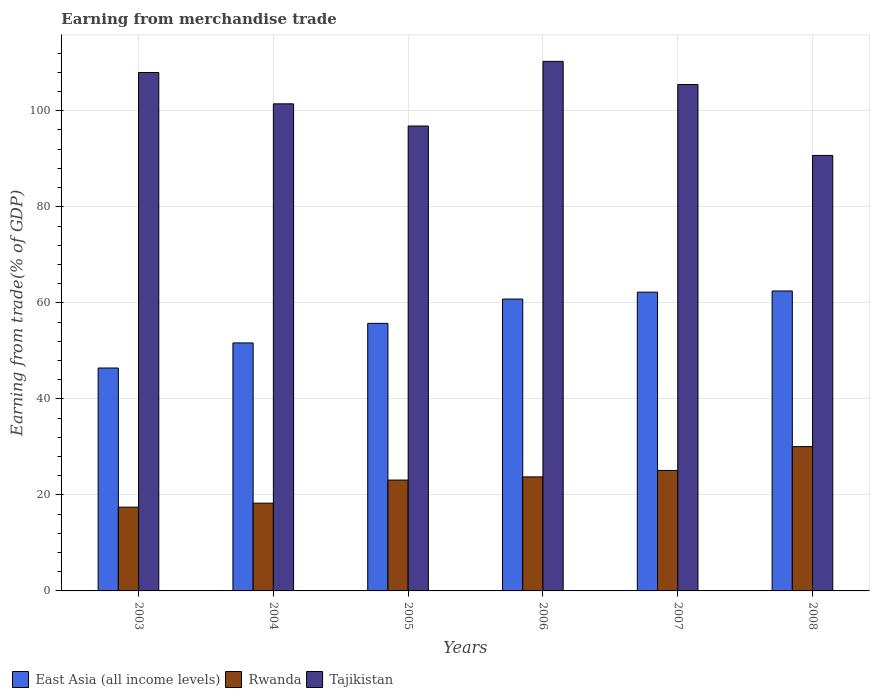Are the number of bars per tick equal to the number of legend labels?
Offer a very short reply. Yes. What is the label of the 4th group of bars from the left?
Give a very brief answer. 2006. What is the earnings from trade in Tajikistan in 2003?
Offer a very short reply. 107.97. Across all years, what is the maximum earnings from trade in Tajikistan?
Your response must be concise. 110.29. Across all years, what is the minimum earnings from trade in Rwanda?
Offer a terse response. 17.44. In which year was the earnings from trade in East Asia (all income levels) minimum?
Give a very brief answer. 2003. What is the total earnings from trade in Tajikistan in the graph?
Your answer should be compact. 612.71. What is the difference between the earnings from trade in East Asia (all income levels) in 2004 and that in 2006?
Ensure brevity in your answer.  -9.14. What is the difference between the earnings from trade in Rwanda in 2008 and the earnings from trade in Tajikistan in 2006?
Keep it short and to the point. -80.24. What is the average earnings from trade in Tajikistan per year?
Offer a terse response. 102.12. In the year 2004, what is the difference between the earnings from trade in East Asia (all income levels) and earnings from trade in Rwanda?
Ensure brevity in your answer.  33.37. In how many years, is the earnings from trade in Rwanda greater than 12 %?
Keep it short and to the point. 6. What is the ratio of the earnings from trade in East Asia (all income levels) in 2003 to that in 2005?
Ensure brevity in your answer.  0.83. What is the difference between the highest and the second highest earnings from trade in Tajikistan?
Offer a very short reply. 2.32. What is the difference between the highest and the lowest earnings from trade in Tajikistan?
Your response must be concise. 19.59. Is the sum of the earnings from trade in East Asia (all income levels) in 2003 and 2006 greater than the maximum earnings from trade in Tajikistan across all years?
Offer a terse response. No. What does the 2nd bar from the left in 2006 represents?
Ensure brevity in your answer.  Rwanda. What does the 3rd bar from the right in 2006 represents?
Ensure brevity in your answer.  East Asia (all income levels). How many bars are there?
Ensure brevity in your answer.  18. Are all the bars in the graph horizontal?
Ensure brevity in your answer.  No. What is the difference between two consecutive major ticks on the Y-axis?
Ensure brevity in your answer.  20. Does the graph contain any zero values?
Make the answer very short. No. Where does the legend appear in the graph?
Make the answer very short. Bottom left. How many legend labels are there?
Keep it short and to the point. 3. What is the title of the graph?
Ensure brevity in your answer.  Earning from merchandise trade. Does "Faeroe Islands" appear as one of the legend labels in the graph?
Provide a succinct answer. No. What is the label or title of the Y-axis?
Offer a terse response. Earning from trade(% of GDP). What is the Earning from trade(% of GDP) in East Asia (all income levels) in 2003?
Offer a very short reply. 46.43. What is the Earning from trade(% of GDP) in Rwanda in 2003?
Make the answer very short. 17.44. What is the Earning from trade(% of GDP) in Tajikistan in 2003?
Provide a succinct answer. 107.97. What is the Earning from trade(% of GDP) in East Asia (all income levels) in 2004?
Provide a succinct answer. 51.65. What is the Earning from trade(% of GDP) in Rwanda in 2004?
Your response must be concise. 18.28. What is the Earning from trade(% of GDP) of Tajikistan in 2004?
Provide a succinct answer. 101.45. What is the Earning from trade(% of GDP) in East Asia (all income levels) in 2005?
Ensure brevity in your answer.  55.72. What is the Earning from trade(% of GDP) in Rwanda in 2005?
Ensure brevity in your answer.  23.09. What is the Earning from trade(% of GDP) in Tajikistan in 2005?
Offer a terse response. 96.83. What is the Earning from trade(% of GDP) in East Asia (all income levels) in 2006?
Ensure brevity in your answer.  60.79. What is the Earning from trade(% of GDP) of Rwanda in 2006?
Give a very brief answer. 23.75. What is the Earning from trade(% of GDP) in Tajikistan in 2006?
Offer a terse response. 110.29. What is the Earning from trade(% of GDP) in East Asia (all income levels) in 2007?
Your answer should be compact. 62.22. What is the Earning from trade(% of GDP) in Rwanda in 2007?
Your answer should be very brief. 25.09. What is the Earning from trade(% of GDP) of Tajikistan in 2007?
Your response must be concise. 105.47. What is the Earning from trade(% of GDP) of East Asia (all income levels) in 2008?
Offer a very short reply. 62.47. What is the Earning from trade(% of GDP) of Rwanda in 2008?
Offer a terse response. 30.06. What is the Earning from trade(% of GDP) of Tajikistan in 2008?
Your answer should be very brief. 90.7. Across all years, what is the maximum Earning from trade(% of GDP) of East Asia (all income levels)?
Your answer should be compact. 62.47. Across all years, what is the maximum Earning from trade(% of GDP) of Rwanda?
Keep it short and to the point. 30.06. Across all years, what is the maximum Earning from trade(% of GDP) in Tajikistan?
Give a very brief answer. 110.29. Across all years, what is the minimum Earning from trade(% of GDP) of East Asia (all income levels)?
Provide a short and direct response. 46.43. Across all years, what is the minimum Earning from trade(% of GDP) of Rwanda?
Your answer should be compact. 17.44. Across all years, what is the minimum Earning from trade(% of GDP) of Tajikistan?
Your answer should be compact. 90.7. What is the total Earning from trade(% of GDP) of East Asia (all income levels) in the graph?
Offer a very short reply. 339.28. What is the total Earning from trade(% of GDP) in Rwanda in the graph?
Your answer should be very brief. 137.71. What is the total Earning from trade(% of GDP) in Tajikistan in the graph?
Keep it short and to the point. 612.71. What is the difference between the Earning from trade(% of GDP) in East Asia (all income levels) in 2003 and that in 2004?
Offer a very short reply. -5.22. What is the difference between the Earning from trade(% of GDP) in Rwanda in 2003 and that in 2004?
Your response must be concise. -0.84. What is the difference between the Earning from trade(% of GDP) in Tajikistan in 2003 and that in 2004?
Keep it short and to the point. 6.52. What is the difference between the Earning from trade(% of GDP) of East Asia (all income levels) in 2003 and that in 2005?
Keep it short and to the point. -9.3. What is the difference between the Earning from trade(% of GDP) in Rwanda in 2003 and that in 2005?
Your answer should be compact. -5.65. What is the difference between the Earning from trade(% of GDP) in Tajikistan in 2003 and that in 2005?
Your answer should be compact. 11.14. What is the difference between the Earning from trade(% of GDP) of East Asia (all income levels) in 2003 and that in 2006?
Your answer should be compact. -14.36. What is the difference between the Earning from trade(% of GDP) in Rwanda in 2003 and that in 2006?
Provide a succinct answer. -6.31. What is the difference between the Earning from trade(% of GDP) of Tajikistan in 2003 and that in 2006?
Your answer should be compact. -2.32. What is the difference between the Earning from trade(% of GDP) of East Asia (all income levels) in 2003 and that in 2007?
Offer a very short reply. -15.8. What is the difference between the Earning from trade(% of GDP) of Rwanda in 2003 and that in 2007?
Your response must be concise. -7.65. What is the difference between the Earning from trade(% of GDP) of East Asia (all income levels) in 2003 and that in 2008?
Your answer should be compact. -16.04. What is the difference between the Earning from trade(% of GDP) in Rwanda in 2003 and that in 2008?
Offer a very short reply. -12.61. What is the difference between the Earning from trade(% of GDP) of Tajikistan in 2003 and that in 2008?
Provide a short and direct response. 17.27. What is the difference between the Earning from trade(% of GDP) in East Asia (all income levels) in 2004 and that in 2005?
Your response must be concise. -4.08. What is the difference between the Earning from trade(% of GDP) of Rwanda in 2004 and that in 2005?
Provide a short and direct response. -4.81. What is the difference between the Earning from trade(% of GDP) in Tajikistan in 2004 and that in 2005?
Your answer should be compact. 4.62. What is the difference between the Earning from trade(% of GDP) of East Asia (all income levels) in 2004 and that in 2006?
Your answer should be very brief. -9.14. What is the difference between the Earning from trade(% of GDP) of Rwanda in 2004 and that in 2006?
Your response must be concise. -5.47. What is the difference between the Earning from trade(% of GDP) in Tajikistan in 2004 and that in 2006?
Your response must be concise. -8.85. What is the difference between the Earning from trade(% of GDP) of East Asia (all income levels) in 2004 and that in 2007?
Offer a terse response. -10.57. What is the difference between the Earning from trade(% of GDP) in Rwanda in 2004 and that in 2007?
Offer a terse response. -6.81. What is the difference between the Earning from trade(% of GDP) in Tajikistan in 2004 and that in 2007?
Provide a short and direct response. -4.02. What is the difference between the Earning from trade(% of GDP) of East Asia (all income levels) in 2004 and that in 2008?
Make the answer very short. -10.82. What is the difference between the Earning from trade(% of GDP) of Rwanda in 2004 and that in 2008?
Offer a terse response. -11.78. What is the difference between the Earning from trade(% of GDP) of Tajikistan in 2004 and that in 2008?
Offer a terse response. 10.75. What is the difference between the Earning from trade(% of GDP) of East Asia (all income levels) in 2005 and that in 2006?
Make the answer very short. -5.06. What is the difference between the Earning from trade(% of GDP) in Rwanda in 2005 and that in 2006?
Keep it short and to the point. -0.66. What is the difference between the Earning from trade(% of GDP) of Tajikistan in 2005 and that in 2006?
Your answer should be compact. -13.47. What is the difference between the Earning from trade(% of GDP) in East Asia (all income levels) in 2005 and that in 2007?
Make the answer very short. -6.5. What is the difference between the Earning from trade(% of GDP) in Rwanda in 2005 and that in 2007?
Your answer should be compact. -2. What is the difference between the Earning from trade(% of GDP) of Tajikistan in 2005 and that in 2007?
Provide a succinct answer. -8.64. What is the difference between the Earning from trade(% of GDP) of East Asia (all income levels) in 2005 and that in 2008?
Your response must be concise. -6.75. What is the difference between the Earning from trade(% of GDP) in Rwanda in 2005 and that in 2008?
Give a very brief answer. -6.97. What is the difference between the Earning from trade(% of GDP) in Tajikistan in 2005 and that in 2008?
Provide a succinct answer. 6.13. What is the difference between the Earning from trade(% of GDP) of East Asia (all income levels) in 2006 and that in 2007?
Give a very brief answer. -1.44. What is the difference between the Earning from trade(% of GDP) in Rwanda in 2006 and that in 2007?
Your answer should be very brief. -1.34. What is the difference between the Earning from trade(% of GDP) of Tajikistan in 2006 and that in 2007?
Offer a terse response. 4.82. What is the difference between the Earning from trade(% of GDP) of East Asia (all income levels) in 2006 and that in 2008?
Keep it short and to the point. -1.68. What is the difference between the Earning from trade(% of GDP) in Rwanda in 2006 and that in 2008?
Keep it short and to the point. -6.31. What is the difference between the Earning from trade(% of GDP) in Tajikistan in 2006 and that in 2008?
Provide a succinct answer. 19.59. What is the difference between the Earning from trade(% of GDP) in East Asia (all income levels) in 2007 and that in 2008?
Give a very brief answer. -0.25. What is the difference between the Earning from trade(% of GDP) of Rwanda in 2007 and that in 2008?
Provide a succinct answer. -4.96. What is the difference between the Earning from trade(% of GDP) in Tajikistan in 2007 and that in 2008?
Give a very brief answer. 14.77. What is the difference between the Earning from trade(% of GDP) in East Asia (all income levels) in 2003 and the Earning from trade(% of GDP) in Rwanda in 2004?
Keep it short and to the point. 28.15. What is the difference between the Earning from trade(% of GDP) in East Asia (all income levels) in 2003 and the Earning from trade(% of GDP) in Tajikistan in 2004?
Your response must be concise. -55.02. What is the difference between the Earning from trade(% of GDP) in Rwanda in 2003 and the Earning from trade(% of GDP) in Tajikistan in 2004?
Your response must be concise. -84. What is the difference between the Earning from trade(% of GDP) in East Asia (all income levels) in 2003 and the Earning from trade(% of GDP) in Rwanda in 2005?
Your answer should be very brief. 23.34. What is the difference between the Earning from trade(% of GDP) in East Asia (all income levels) in 2003 and the Earning from trade(% of GDP) in Tajikistan in 2005?
Give a very brief answer. -50.4. What is the difference between the Earning from trade(% of GDP) in Rwanda in 2003 and the Earning from trade(% of GDP) in Tajikistan in 2005?
Offer a very short reply. -79.38. What is the difference between the Earning from trade(% of GDP) in East Asia (all income levels) in 2003 and the Earning from trade(% of GDP) in Rwanda in 2006?
Keep it short and to the point. 22.68. What is the difference between the Earning from trade(% of GDP) of East Asia (all income levels) in 2003 and the Earning from trade(% of GDP) of Tajikistan in 2006?
Make the answer very short. -63.87. What is the difference between the Earning from trade(% of GDP) in Rwanda in 2003 and the Earning from trade(% of GDP) in Tajikistan in 2006?
Provide a succinct answer. -92.85. What is the difference between the Earning from trade(% of GDP) in East Asia (all income levels) in 2003 and the Earning from trade(% of GDP) in Rwanda in 2007?
Your answer should be compact. 21.33. What is the difference between the Earning from trade(% of GDP) of East Asia (all income levels) in 2003 and the Earning from trade(% of GDP) of Tajikistan in 2007?
Your response must be concise. -59.04. What is the difference between the Earning from trade(% of GDP) of Rwanda in 2003 and the Earning from trade(% of GDP) of Tajikistan in 2007?
Your answer should be compact. -88.03. What is the difference between the Earning from trade(% of GDP) of East Asia (all income levels) in 2003 and the Earning from trade(% of GDP) of Rwanda in 2008?
Your answer should be very brief. 16.37. What is the difference between the Earning from trade(% of GDP) of East Asia (all income levels) in 2003 and the Earning from trade(% of GDP) of Tajikistan in 2008?
Your response must be concise. -44.27. What is the difference between the Earning from trade(% of GDP) in Rwanda in 2003 and the Earning from trade(% of GDP) in Tajikistan in 2008?
Offer a terse response. -73.26. What is the difference between the Earning from trade(% of GDP) in East Asia (all income levels) in 2004 and the Earning from trade(% of GDP) in Rwanda in 2005?
Ensure brevity in your answer.  28.56. What is the difference between the Earning from trade(% of GDP) of East Asia (all income levels) in 2004 and the Earning from trade(% of GDP) of Tajikistan in 2005?
Offer a very short reply. -45.18. What is the difference between the Earning from trade(% of GDP) in Rwanda in 2004 and the Earning from trade(% of GDP) in Tajikistan in 2005?
Ensure brevity in your answer.  -78.55. What is the difference between the Earning from trade(% of GDP) of East Asia (all income levels) in 2004 and the Earning from trade(% of GDP) of Rwanda in 2006?
Your response must be concise. 27.9. What is the difference between the Earning from trade(% of GDP) of East Asia (all income levels) in 2004 and the Earning from trade(% of GDP) of Tajikistan in 2006?
Provide a succinct answer. -58.65. What is the difference between the Earning from trade(% of GDP) in Rwanda in 2004 and the Earning from trade(% of GDP) in Tajikistan in 2006?
Ensure brevity in your answer.  -92.02. What is the difference between the Earning from trade(% of GDP) in East Asia (all income levels) in 2004 and the Earning from trade(% of GDP) in Rwanda in 2007?
Your response must be concise. 26.56. What is the difference between the Earning from trade(% of GDP) in East Asia (all income levels) in 2004 and the Earning from trade(% of GDP) in Tajikistan in 2007?
Offer a terse response. -53.82. What is the difference between the Earning from trade(% of GDP) of Rwanda in 2004 and the Earning from trade(% of GDP) of Tajikistan in 2007?
Keep it short and to the point. -87.19. What is the difference between the Earning from trade(% of GDP) in East Asia (all income levels) in 2004 and the Earning from trade(% of GDP) in Rwanda in 2008?
Offer a terse response. 21.59. What is the difference between the Earning from trade(% of GDP) of East Asia (all income levels) in 2004 and the Earning from trade(% of GDP) of Tajikistan in 2008?
Provide a succinct answer. -39.05. What is the difference between the Earning from trade(% of GDP) of Rwanda in 2004 and the Earning from trade(% of GDP) of Tajikistan in 2008?
Make the answer very short. -72.42. What is the difference between the Earning from trade(% of GDP) in East Asia (all income levels) in 2005 and the Earning from trade(% of GDP) in Rwanda in 2006?
Your response must be concise. 31.98. What is the difference between the Earning from trade(% of GDP) of East Asia (all income levels) in 2005 and the Earning from trade(% of GDP) of Tajikistan in 2006?
Your answer should be compact. -54.57. What is the difference between the Earning from trade(% of GDP) in Rwanda in 2005 and the Earning from trade(% of GDP) in Tajikistan in 2006?
Make the answer very short. -87.21. What is the difference between the Earning from trade(% of GDP) of East Asia (all income levels) in 2005 and the Earning from trade(% of GDP) of Rwanda in 2007?
Your answer should be compact. 30.63. What is the difference between the Earning from trade(% of GDP) of East Asia (all income levels) in 2005 and the Earning from trade(% of GDP) of Tajikistan in 2007?
Offer a terse response. -49.75. What is the difference between the Earning from trade(% of GDP) in Rwanda in 2005 and the Earning from trade(% of GDP) in Tajikistan in 2007?
Provide a succinct answer. -82.38. What is the difference between the Earning from trade(% of GDP) in East Asia (all income levels) in 2005 and the Earning from trade(% of GDP) in Rwanda in 2008?
Make the answer very short. 25.67. What is the difference between the Earning from trade(% of GDP) in East Asia (all income levels) in 2005 and the Earning from trade(% of GDP) in Tajikistan in 2008?
Provide a short and direct response. -34.98. What is the difference between the Earning from trade(% of GDP) of Rwanda in 2005 and the Earning from trade(% of GDP) of Tajikistan in 2008?
Provide a short and direct response. -67.61. What is the difference between the Earning from trade(% of GDP) in East Asia (all income levels) in 2006 and the Earning from trade(% of GDP) in Rwanda in 2007?
Your answer should be compact. 35.69. What is the difference between the Earning from trade(% of GDP) of East Asia (all income levels) in 2006 and the Earning from trade(% of GDP) of Tajikistan in 2007?
Your answer should be very brief. -44.68. What is the difference between the Earning from trade(% of GDP) in Rwanda in 2006 and the Earning from trade(% of GDP) in Tajikistan in 2007?
Make the answer very short. -81.72. What is the difference between the Earning from trade(% of GDP) in East Asia (all income levels) in 2006 and the Earning from trade(% of GDP) in Rwanda in 2008?
Provide a succinct answer. 30.73. What is the difference between the Earning from trade(% of GDP) of East Asia (all income levels) in 2006 and the Earning from trade(% of GDP) of Tajikistan in 2008?
Offer a terse response. -29.91. What is the difference between the Earning from trade(% of GDP) in Rwanda in 2006 and the Earning from trade(% of GDP) in Tajikistan in 2008?
Keep it short and to the point. -66.95. What is the difference between the Earning from trade(% of GDP) in East Asia (all income levels) in 2007 and the Earning from trade(% of GDP) in Rwanda in 2008?
Your answer should be compact. 32.17. What is the difference between the Earning from trade(% of GDP) of East Asia (all income levels) in 2007 and the Earning from trade(% of GDP) of Tajikistan in 2008?
Offer a terse response. -28.48. What is the difference between the Earning from trade(% of GDP) of Rwanda in 2007 and the Earning from trade(% of GDP) of Tajikistan in 2008?
Offer a very short reply. -65.61. What is the average Earning from trade(% of GDP) in East Asia (all income levels) per year?
Give a very brief answer. 56.55. What is the average Earning from trade(% of GDP) of Rwanda per year?
Your response must be concise. 22.95. What is the average Earning from trade(% of GDP) in Tajikistan per year?
Offer a terse response. 102.12. In the year 2003, what is the difference between the Earning from trade(% of GDP) in East Asia (all income levels) and Earning from trade(% of GDP) in Rwanda?
Make the answer very short. 28.98. In the year 2003, what is the difference between the Earning from trade(% of GDP) in East Asia (all income levels) and Earning from trade(% of GDP) in Tajikistan?
Ensure brevity in your answer.  -61.54. In the year 2003, what is the difference between the Earning from trade(% of GDP) in Rwanda and Earning from trade(% of GDP) in Tajikistan?
Make the answer very short. -90.53. In the year 2004, what is the difference between the Earning from trade(% of GDP) of East Asia (all income levels) and Earning from trade(% of GDP) of Rwanda?
Provide a short and direct response. 33.37. In the year 2004, what is the difference between the Earning from trade(% of GDP) of East Asia (all income levels) and Earning from trade(% of GDP) of Tajikistan?
Your answer should be very brief. -49.8. In the year 2004, what is the difference between the Earning from trade(% of GDP) in Rwanda and Earning from trade(% of GDP) in Tajikistan?
Provide a succinct answer. -83.17. In the year 2005, what is the difference between the Earning from trade(% of GDP) in East Asia (all income levels) and Earning from trade(% of GDP) in Rwanda?
Offer a terse response. 32.64. In the year 2005, what is the difference between the Earning from trade(% of GDP) in East Asia (all income levels) and Earning from trade(% of GDP) in Tajikistan?
Make the answer very short. -41.1. In the year 2005, what is the difference between the Earning from trade(% of GDP) in Rwanda and Earning from trade(% of GDP) in Tajikistan?
Offer a terse response. -73.74. In the year 2006, what is the difference between the Earning from trade(% of GDP) of East Asia (all income levels) and Earning from trade(% of GDP) of Rwanda?
Make the answer very short. 37.04. In the year 2006, what is the difference between the Earning from trade(% of GDP) of East Asia (all income levels) and Earning from trade(% of GDP) of Tajikistan?
Ensure brevity in your answer.  -49.51. In the year 2006, what is the difference between the Earning from trade(% of GDP) in Rwanda and Earning from trade(% of GDP) in Tajikistan?
Give a very brief answer. -86.55. In the year 2007, what is the difference between the Earning from trade(% of GDP) in East Asia (all income levels) and Earning from trade(% of GDP) in Rwanda?
Your answer should be compact. 37.13. In the year 2007, what is the difference between the Earning from trade(% of GDP) in East Asia (all income levels) and Earning from trade(% of GDP) in Tajikistan?
Your answer should be very brief. -43.25. In the year 2007, what is the difference between the Earning from trade(% of GDP) in Rwanda and Earning from trade(% of GDP) in Tajikistan?
Offer a very short reply. -80.38. In the year 2008, what is the difference between the Earning from trade(% of GDP) in East Asia (all income levels) and Earning from trade(% of GDP) in Rwanda?
Provide a succinct answer. 32.41. In the year 2008, what is the difference between the Earning from trade(% of GDP) of East Asia (all income levels) and Earning from trade(% of GDP) of Tajikistan?
Ensure brevity in your answer.  -28.23. In the year 2008, what is the difference between the Earning from trade(% of GDP) in Rwanda and Earning from trade(% of GDP) in Tajikistan?
Offer a terse response. -60.64. What is the ratio of the Earning from trade(% of GDP) of East Asia (all income levels) in 2003 to that in 2004?
Provide a succinct answer. 0.9. What is the ratio of the Earning from trade(% of GDP) in Rwanda in 2003 to that in 2004?
Provide a short and direct response. 0.95. What is the ratio of the Earning from trade(% of GDP) in Tajikistan in 2003 to that in 2004?
Keep it short and to the point. 1.06. What is the ratio of the Earning from trade(% of GDP) of East Asia (all income levels) in 2003 to that in 2005?
Offer a terse response. 0.83. What is the ratio of the Earning from trade(% of GDP) of Rwanda in 2003 to that in 2005?
Your answer should be very brief. 0.76. What is the ratio of the Earning from trade(% of GDP) of Tajikistan in 2003 to that in 2005?
Offer a terse response. 1.12. What is the ratio of the Earning from trade(% of GDP) of East Asia (all income levels) in 2003 to that in 2006?
Your answer should be compact. 0.76. What is the ratio of the Earning from trade(% of GDP) in Rwanda in 2003 to that in 2006?
Provide a succinct answer. 0.73. What is the ratio of the Earning from trade(% of GDP) in Tajikistan in 2003 to that in 2006?
Give a very brief answer. 0.98. What is the ratio of the Earning from trade(% of GDP) of East Asia (all income levels) in 2003 to that in 2007?
Give a very brief answer. 0.75. What is the ratio of the Earning from trade(% of GDP) of Rwanda in 2003 to that in 2007?
Your answer should be very brief. 0.7. What is the ratio of the Earning from trade(% of GDP) in Tajikistan in 2003 to that in 2007?
Make the answer very short. 1.02. What is the ratio of the Earning from trade(% of GDP) of East Asia (all income levels) in 2003 to that in 2008?
Your answer should be very brief. 0.74. What is the ratio of the Earning from trade(% of GDP) of Rwanda in 2003 to that in 2008?
Keep it short and to the point. 0.58. What is the ratio of the Earning from trade(% of GDP) of Tajikistan in 2003 to that in 2008?
Keep it short and to the point. 1.19. What is the ratio of the Earning from trade(% of GDP) in East Asia (all income levels) in 2004 to that in 2005?
Make the answer very short. 0.93. What is the ratio of the Earning from trade(% of GDP) of Rwanda in 2004 to that in 2005?
Your response must be concise. 0.79. What is the ratio of the Earning from trade(% of GDP) of Tajikistan in 2004 to that in 2005?
Keep it short and to the point. 1.05. What is the ratio of the Earning from trade(% of GDP) of East Asia (all income levels) in 2004 to that in 2006?
Keep it short and to the point. 0.85. What is the ratio of the Earning from trade(% of GDP) in Rwanda in 2004 to that in 2006?
Offer a terse response. 0.77. What is the ratio of the Earning from trade(% of GDP) in Tajikistan in 2004 to that in 2006?
Your answer should be very brief. 0.92. What is the ratio of the Earning from trade(% of GDP) in East Asia (all income levels) in 2004 to that in 2007?
Offer a terse response. 0.83. What is the ratio of the Earning from trade(% of GDP) in Rwanda in 2004 to that in 2007?
Offer a very short reply. 0.73. What is the ratio of the Earning from trade(% of GDP) of Tajikistan in 2004 to that in 2007?
Ensure brevity in your answer.  0.96. What is the ratio of the Earning from trade(% of GDP) in East Asia (all income levels) in 2004 to that in 2008?
Provide a succinct answer. 0.83. What is the ratio of the Earning from trade(% of GDP) in Rwanda in 2004 to that in 2008?
Your response must be concise. 0.61. What is the ratio of the Earning from trade(% of GDP) in Tajikistan in 2004 to that in 2008?
Make the answer very short. 1.12. What is the ratio of the Earning from trade(% of GDP) in East Asia (all income levels) in 2005 to that in 2006?
Your answer should be very brief. 0.92. What is the ratio of the Earning from trade(% of GDP) in Rwanda in 2005 to that in 2006?
Your response must be concise. 0.97. What is the ratio of the Earning from trade(% of GDP) of Tajikistan in 2005 to that in 2006?
Give a very brief answer. 0.88. What is the ratio of the Earning from trade(% of GDP) of East Asia (all income levels) in 2005 to that in 2007?
Offer a very short reply. 0.9. What is the ratio of the Earning from trade(% of GDP) in Rwanda in 2005 to that in 2007?
Keep it short and to the point. 0.92. What is the ratio of the Earning from trade(% of GDP) in Tajikistan in 2005 to that in 2007?
Provide a succinct answer. 0.92. What is the ratio of the Earning from trade(% of GDP) in East Asia (all income levels) in 2005 to that in 2008?
Your response must be concise. 0.89. What is the ratio of the Earning from trade(% of GDP) in Rwanda in 2005 to that in 2008?
Provide a short and direct response. 0.77. What is the ratio of the Earning from trade(% of GDP) of Tajikistan in 2005 to that in 2008?
Offer a very short reply. 1.07. What is the ratio of the Earning from trade(% of GDP) of East Asia (all income levels) in 2006 to that in 2007?
Offer a very short reply. 0.98. What is the ratio of the Earning from trade(% of GDP) in Rwanda in 2006 to that in 2007?
Offer a very short reply. 0.95. What is the ratio of the Earning from trade(% of GDP) in Tajikistan in 2006 to that in 2007?
Keep it short and to the point. 1.05. What is the ratio of the Earning from trade(% of GDP) in East Asia (all income levels) in 2006 to that in 2008?
Give a very brief answer. 0.97. What is the ratio of the Earning from trade(% of GDP) of Rwanda in 2006 to that in 2008?
Provide a short and direct response. 0.79. What is the ratio of the Earning from trade(% of GDP) of Tajikistan in 2006 to that in 2008?
Your answer should be very brief. 1.22. What is the ratio of the Earning from trade(% of GDP) in Rwanda in 2007 to that in 2008?
Keep it short and to the point. 0.83. What is the ratio of the Earning from trade(% of GDP) in Tajikistan in 2007 to that in 2008?
Ensure brevity in your answer.  1.16. What is the difference between the highest and the second highest Earning from trade(% of GDP) of East Asia (all income levels)?
Provide a succinct answer. 0.25. What is the difference between the highest and the second highest Earning from trade(% of GDP) in Rwanda?
Your answer should be very brief. 4.96. What is the difference between the highest and the second highest Earning from trade(% of GDP) of Tajikistan?
Offer a terse response. 2.32. What is the difference between the highest and the lowest Earning from trade(% of GDP) in East Asia (all income levels)?
Offer a terse response. 16.04. What is the difference between the highest and the lowest Earning from trade(% of GDP) of Rwanda?
Offer a terse response. 12.61. What is the difference between the highest and the lowest Earning from trade(% of GDP) of Tajikistan?
Give a very brief answer. 19.59. 